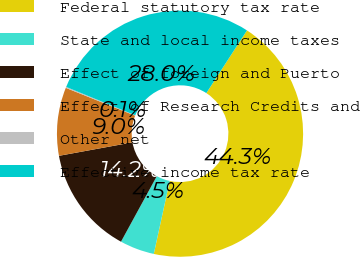<chart> <loc_0><loc_0><loc_500><loc_500><pie_chart><fcel>Federal statutory tax rate<fcel>State and local income taxes<fcel>Effect of foreign and Puerto<fcel>Effect of Research Credits and<fcel>Other net<fcel>Effective income tax rate<nl><fcel>44.26%<fcel>4.54%<fcel>14.16%<fcel>8.95%<fcel>0.13%<fcel>27.95%<nl></chart> 